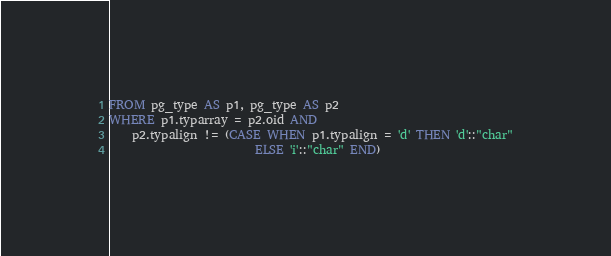<code> <loc_0><loc_0><loc_500><loc_500><_SQL_>FROM pg_type AS p1, pg_type AS p2
WHERE p1.typarray = p2.oid AND
    p2.typalign != (CASE WHEN p1.typalign = 'd' THEN 'd'::"char"
                         ELSE 'i'::"char" END)
</code> 